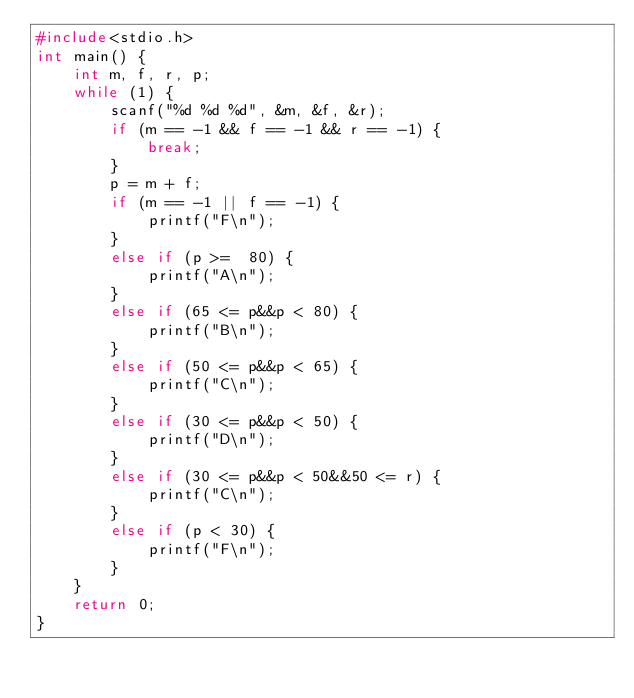<code> <loc_0><loc_0><loc_500><loc_500><_C_>#include<stdio.h>
int main() {
	int m, f, r, p;
	while (1) {
		scanf("%d %d %d", &m, &f, &r);
		if (m == -1 && f == -1 && r == -1) {
			break;
		}
		p = m + f;
		if (m == -1 || f == -1) {
			printf("F\n");
		}
		else if (p >=  80) {
			printf("A\n");
	    }
		else if (65 <= p&&p < 80) {
			printf("B\n");
	    }
		else if (50 <= p&&p < 65) {
			printf("C\n");
		}
		else if (30 <= p&&p < 50) {
			printf("D\n");
		}
		else if (30 <= p&&p < 50&&50 <= r) {
			printf("C\n");
		}
		else if (p < 30) {
			printf("F\n");
		}
	}
	return 0;
}</code> 